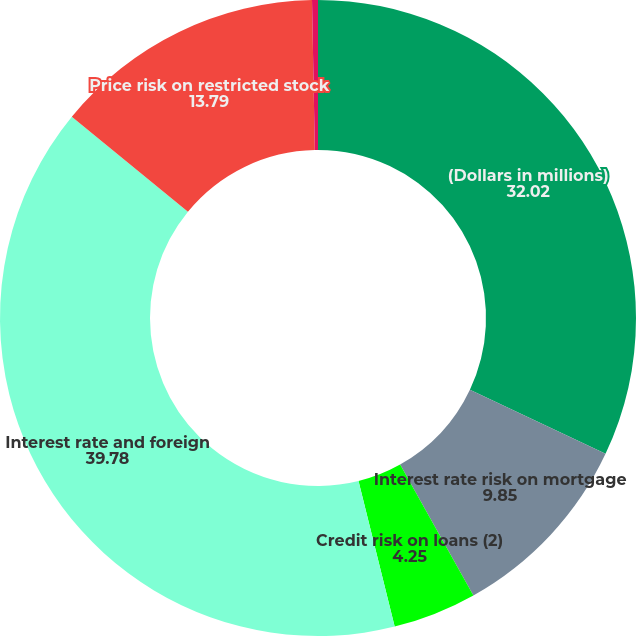Convert chart. <chart><loc_0><loc_0><loc_500><loc_500><pie_chart><fcel>(Dollars in millions)<fcel>Interest rate risk on mortgage<fcel>Credit risk on loans (2)<fcel>Interest rate and foreign<fcel>Price risk on restricted stock<fcel>Other<nl><fcel>32.02%<fcel>9.85%<fcel>4.25%<fcel>39.78%<fcel>13.79%<fcel>0.3%<nl></chart> 